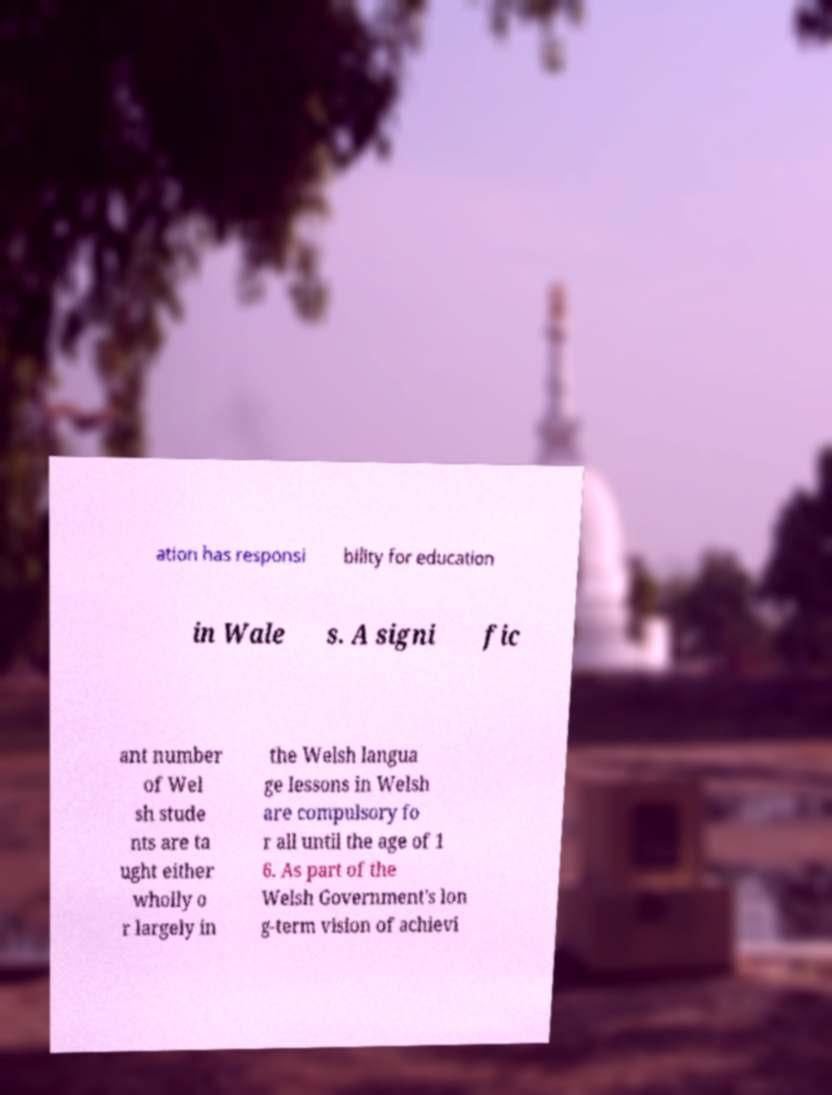For documentation purposes, I need the text within this image transcribed. Could you provide that? ation has responsi bility for education in Wale s. A signi fic ant number of Wel sh stude nts are ta ught either wholly o r largely in the Welsh langua ge lessons in Welsh are compulsory fo r all until the age of 1 6. As part of the Welsh Government's lon g-term vision of achievi 